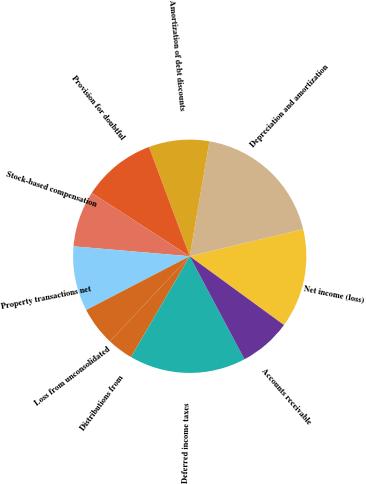Convert chart. <chart><loc_0><loc_0><loc_500><loc_500><pie_chart><fcel>Net income (loss)<fcel>Depreciation and amortization<fcel>Amortization of debt discounts<fcel>Provision for doubtful<fcel>Stock-based compensation<fcel>Property transactions net<fcel>Loss from unconsolidated<fcel>Distributions from<fcel>Deferred income taxes<fcel>Accounts receivable<nl><fcel>13.77%<fcel>18.56%<fcel>8.38%<fcel>10.18%<fcel>7.78%<fcel>8.98%<fcel>5.39%<fcel>3.59%<fcel>16.17%<fcel>7.19%<nl></chart> 